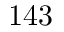<formula> <loc_0><loc_0><loc_500><loc_500>1 4 3</formula> 